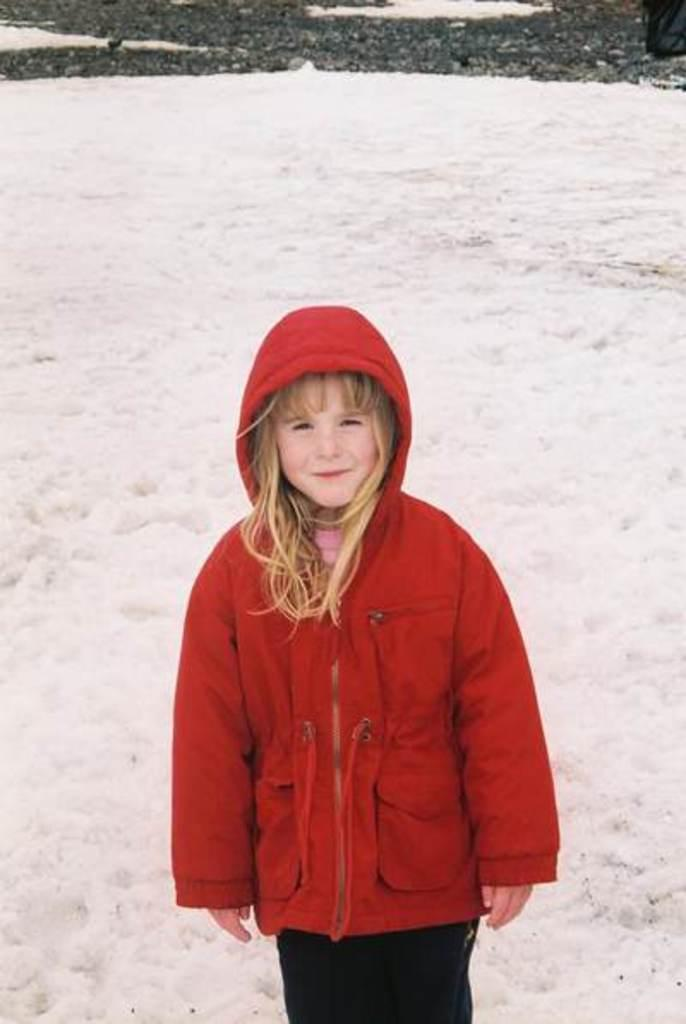What is the main subject in the foreground of the picture? There is a girl in the foreground of the picture. What is the girl wearing in the picture? The girl is wearing a red coat in the picture. What is the surface the girl is standing on? The girl is standing on the snow in the picture. What can be seen in the background of the picture? There is snow and a road visible in the background of the picture. What type of light can be seen illuminating the map in the image? There is no map present in the image, so it is not possible to determine what type of light might be illuminating it. 